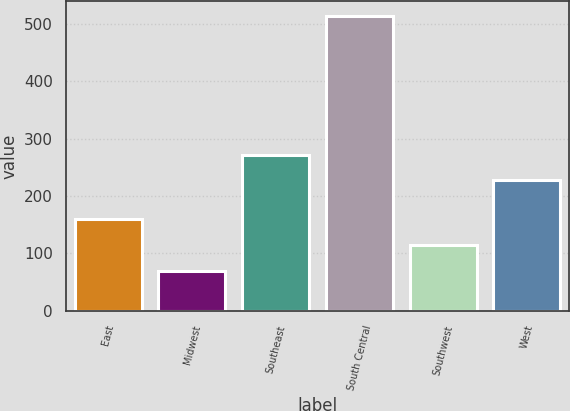<chart> <loc_0><loc_0><loc_500><loc_500><bar_chart><fcel>East<fcel>Midwest<fcel>Southeast<fcel>South Central<fcel>Southwest<fcel>West<nl><fcel>159.64<fcel>68.7<fcel>271.84<fcel>514.1<fcel>115.1<fcel>227.3<nl></chart> 